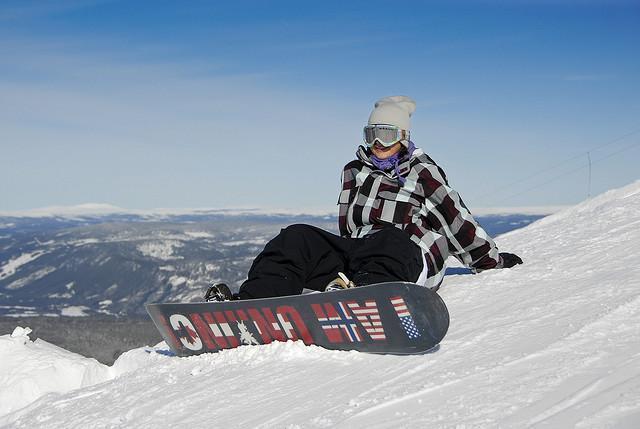How many people are there?
Give a very brief answer. 1. How many red suitcases are there?
Give a very brief answer. 0. 